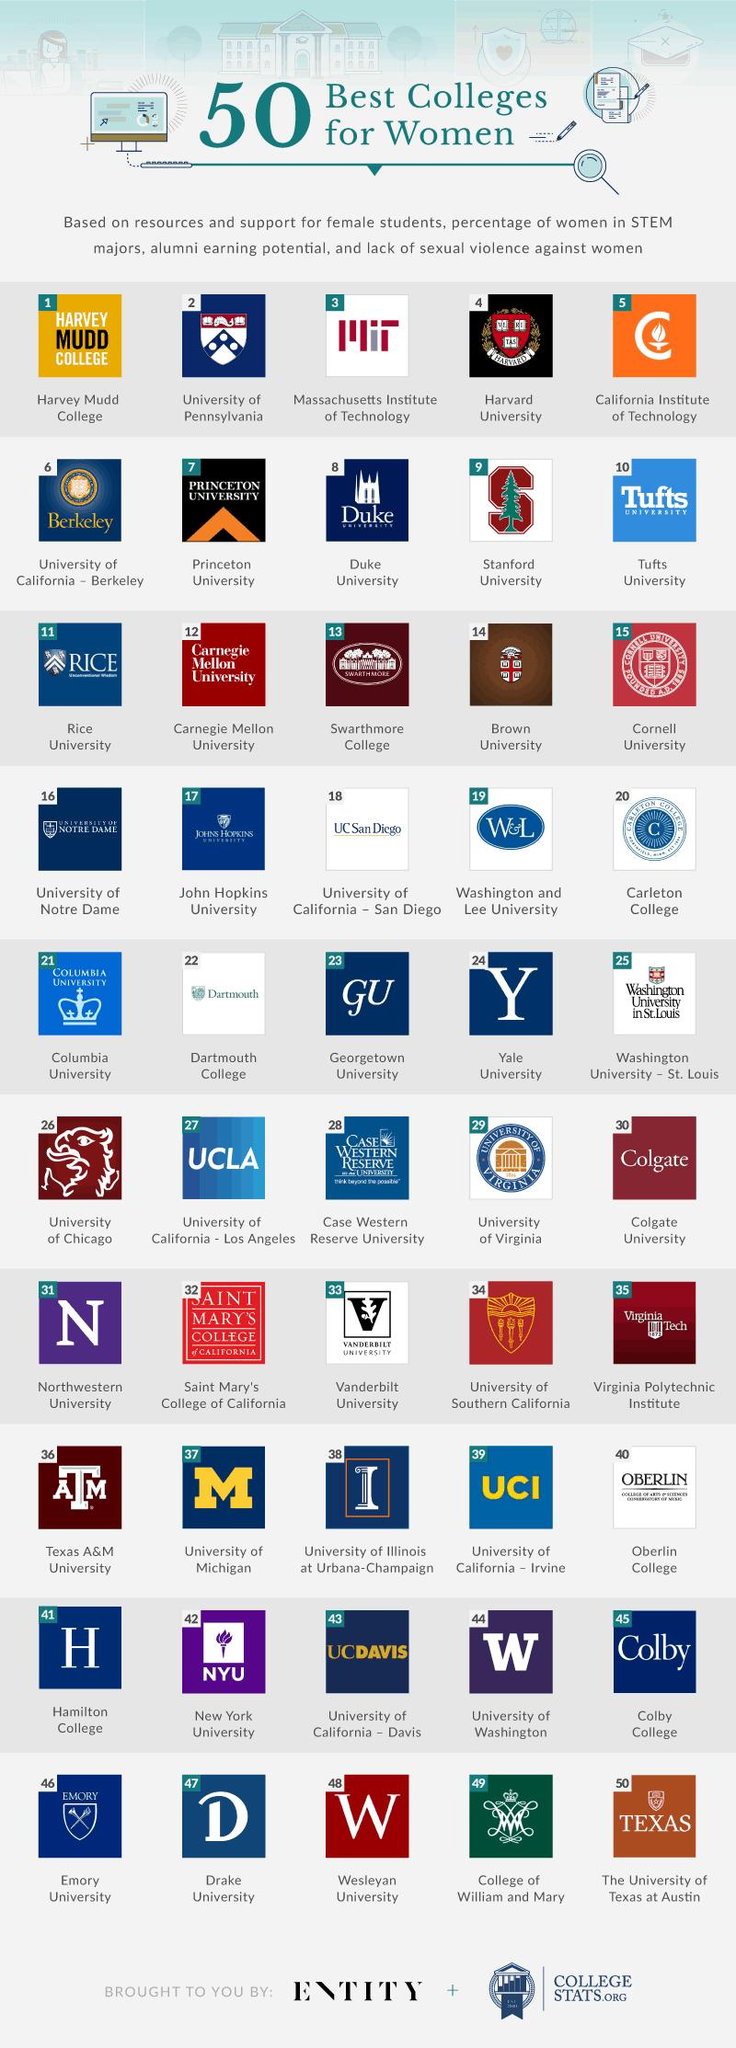Indicate a few pertinent items in this graphic. The background color for the Tufts university logo is blue. Harvard University is considered the fourth best college for women. 